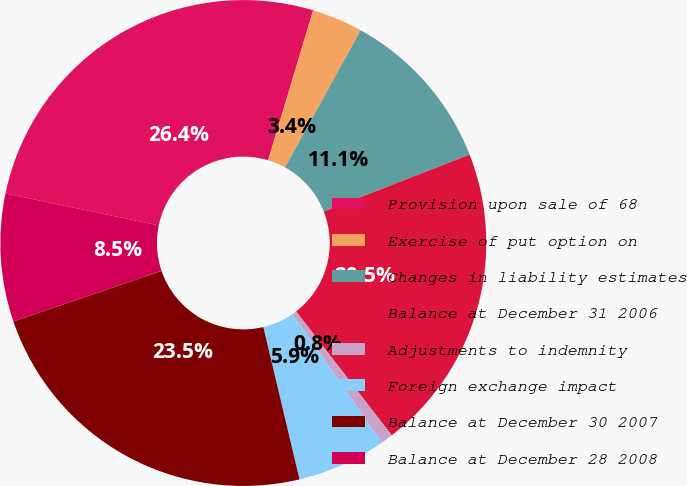<chart> <loc_0><loc_0><loc_500><loc_500><pie_chart><fcel>Provision upon sale of 68<fcel>Exercise of put option on<fcel>Changes in liability estimates<fcel>Balance at December 31 2006<fcel>Adjustments to indemnity<fcel>Foreign exchange impact<fcel>Balance at December 30 2007<fcel>Balance at December 28 2008<nl><fcel>26.37%<fcel>3.38%<fcel>11.05%<fcel>20.47%<fcel>0.8%<fcel>5.94%<fcel>23.48%<fcel>8.5%<nl></chart> 